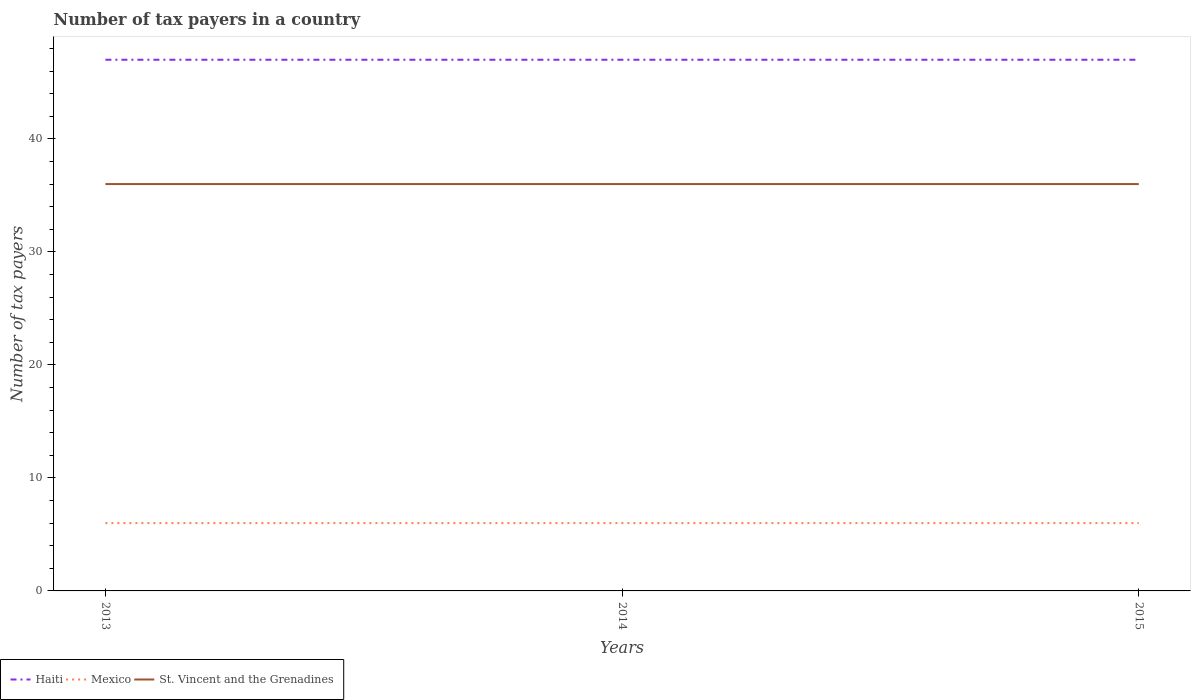Does the line corresponding to Haiti intersect with the line corresponding to St. Vincent and the Grenadines?
Offer a terse response. No. Across all years, what is the maximum number of tax payers in in St. Vincent and the Grenadines?
Offer a very short reply. 36. In which year was the number of tax payers in in Haiti maximum?
Offer a terse response. 2013. What is the total number of tax payers in in Mexico in the graph?
Give a very brief answer. 0. What is the difference between the highest and the second highest number of tax payers in in St. Vincent and the Grenadines?
Your answer should be very brief. 0. How many years are there in the graph?
Offer a very short reply. 3. Are the values on the major ticks of Y-axis written in scientific E-notation?
Your response must be concise. No. What is the title of the graph?
Provide a short and direct response. Number of tax payers in a country. What is the label or title of the Y-axis?
Keep it short and to the point. Number of tax payers. What is the Number of tax payers in Haiti in 2014?
Your answer should be very brief. 47. What is the Number of tax payers in Mexico in 2014?
Provide a short and direct response. 6. Across all years, what is the maximum Number of tax payers in St. Vincent and the Grenadines?
Keep it short and to the point. 36. Across all years, what is the minimum Number of tax payers of Haiti?
Give a very brief answer. 47. Across all years, what is the minimum Number of tax payers in Mexico?
Offer a terse response. 6. Across all years, what is the minimum Number of tax payers of St. Vincent and the Grenadines?
Make the answer very short. 36. What is the total Number of tax payers in Haiti in the graph?
Ensure brevity in your answer.  141. What is the total Number of tax payers in Mexico in the graph?
Your answer should be compact. 18. What is the total Number of tax payers of St. Vincent and the Grenadines in the graph?
Offer a very short reply. 108. What is the difference between the Number of tax payers of Haiti in 2013 and that in 2014?
Offer a very short reply. 0. What is the difference between the Number of tax payers in St. Vincent and the Grenadines in 2013 and that in 2015?
Ensure brevity in your answer.  0. What is the difference between the Number of tax payers in Mexico in 2014 and that in 2015?
Offer a terse response. 0. What is the difference between the Number of tax payers of St. Vincent and the Grenadines in 2014 and that in 2015?
Keep it short and to the point. 0. What is the difference between the Number of tax payers of Haiti in 2013 and the Number of tax payers of Mexico in 2014?
Your answer should be very brief. 41. What is the difference between the Number of tax payers in Haiti in 2013 and the Number of tax payers in St. Vincent and the Grenadines in 2014?
Offer a terse response. 11. What is the difference between the Number of tax payers of Mexico in 2013 and the Number of tax payers of St. Vincent and the Grenadines in 2014?
Provide a succinct answer. -30. What is the difference between the Number of tax payers in Haiti in 2013 and the Number of tax payers in Mexico in 2015?
Make the answer very short. 41. What is the difference between the Number of tax payers in Haiti in 2013 and the Number of tax payers in St. Vincent and the Grenadines in 2015?
Offer a very short reply. 11. What is the difference between the Number of tax payers of Haiti in 2014 and the Number of tax payers of Mexico in 2015?
Offer a very short reply. 41. What is the difference between the Number of tax payers of Haiti in 2014 and the Number of tax payers of St. Vincent and the Grenadines in 2015?
Give a very brief answer. 11. What is the average Number of tax payers in Haiti per year?
Offer a terse response. 47. In the year 2013, what is the difference between the Number of tax payers of Haiti and Number of tax payers of Mexico?
Your answer should be compact. 41. In the year 2013, what is the difference between the Number of tax payers in Mexico and Number of tax payers in St. Vincent and the Grenadines?
Your response must be concise. -30. In the year 2014, what is the difference between the Number of tax payers in Haiti and Number of tax payers in St. Vincent and the Grenadines?
Your answer should be compact. 11. In the year 2014, what is the difference between the Number of tax payers in Mexico and Number of tax payers in St. Vincent and the Grenadines?
Give a very brief answer. -30. In the year 2015, what is the difference between the Number of tax payers of Haiti and Number of tax payers of St. Vincent and the Grenadines?
Provide a short and direct response. 11. What is the ratio of the Number of tax payers of St. Vincent and the Grenadines in 2013 to that in 2014?
Your answer should be compact. 1. What is the ratio of the Number of tax payers of Mexico in 2013 to that in 2015?
Offer a very short reply. 1. What is the ratio of the Number of tax payers in St. Vincent and the Grenadines in 2014 to that in 2015?
Make the answer very short. 1. What is the difference between the highest and the second highest Number of tax payers in Mexico?
Your response must be concise. 0. 